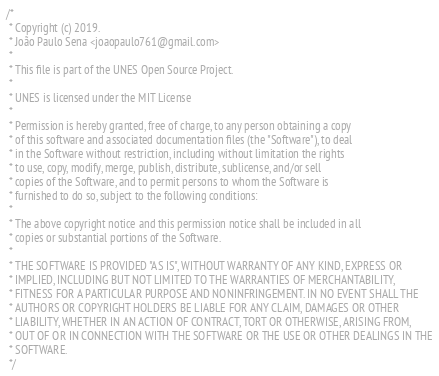Convert code to text. <code><loc_0><loc_0><loc_500><loc_500><_Kotlin_>/*
 * Copyright (c) 2019.
 * João Paulo Sena <joaopaulo761@gmail.com>
 *
 * This file is part of the UNES Open Source Project.
 *
 * UNES is licensed under the MIT License
 *
 * Permission is hereby granted, free of charge, to any person obtaining a copy
 * of this software and associated documentation files (the "Software"), to deal
 * in the Software without restriction, including without limitation the rights
 * to use, copy, modify, merge, publish, distribute, sublicense, and/or sell
 * copies of the Software, and to permit persons to whom the Software is
 * furnished to do so, subject to the following conditions:
 *
 * The above copyright notice and this permission notice shall be included in all
 * copies or substantial portions of the Software.
 *
 * THE SOFTWARE IS PROVIDED "AS IS", WITHOUT WARRANTY OF ANY KIND, EXPRESS OR
 * IMPLIED, INCLUDING BUT NOT LIMITED TO THE WARRANTIES OF MERCHANTABILITY,
 * FITNESS FOR A PARTICULAR PURPOSE AND NONINFRINGEMENT. IN NO EVENT SHALL THE
 * AUTHORS OR COPYRIGHT HOLDERS BE LIABLE FOR ANY CLAIM, DAMAGES OR OTHER
 * LIABILITY, WHETHER IN AN ACTION OF CONTRACT, TORT OR OTHERWISE, ARISING FROM,
 * OUT OF OR IN CONNECTION WITH THE SOFTWARE OR THE USE OR OTHER DEALINGS IN THE
 * SOFTWARE.
 */
</code> 